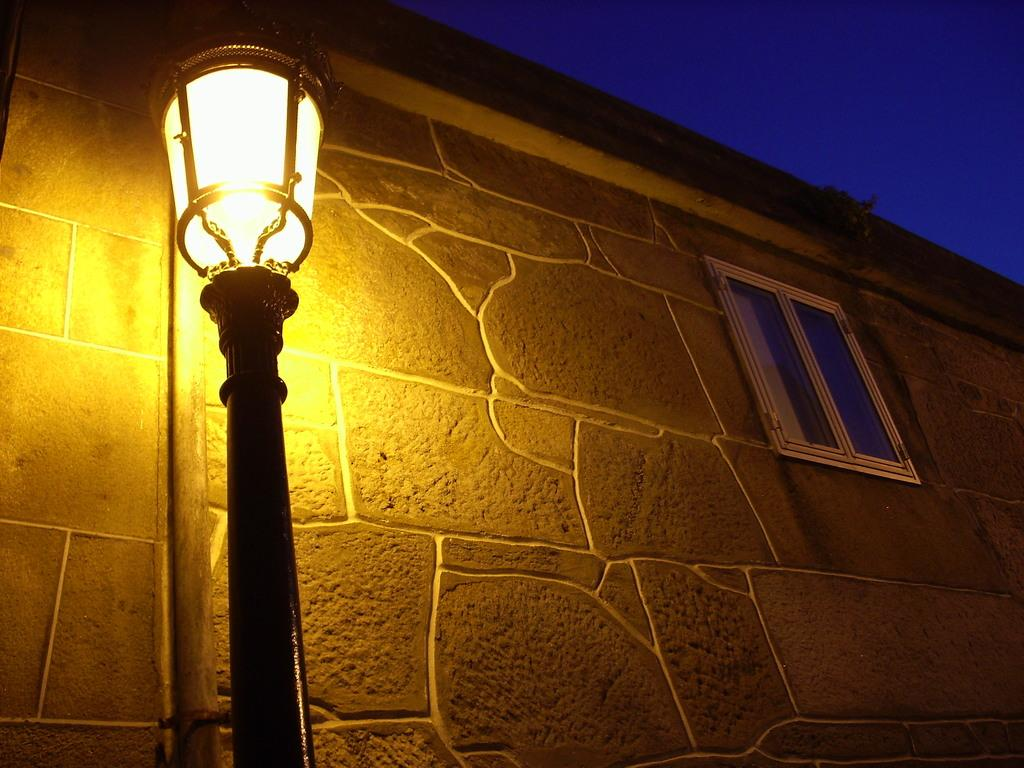What is attached to the pole in the image? There is a light attached to a pole in the image. What can be seen in the background of the image? There is a wall and a window in the background of the image. What is visible in the sky in the image? The sky is visible in the background of the image. How many dogs are visible in the image? There are no dogs present in the image. What type of weather is depicted in the image? The provided facts do not mention any weather conditions, so it cannot be determined from the image. 